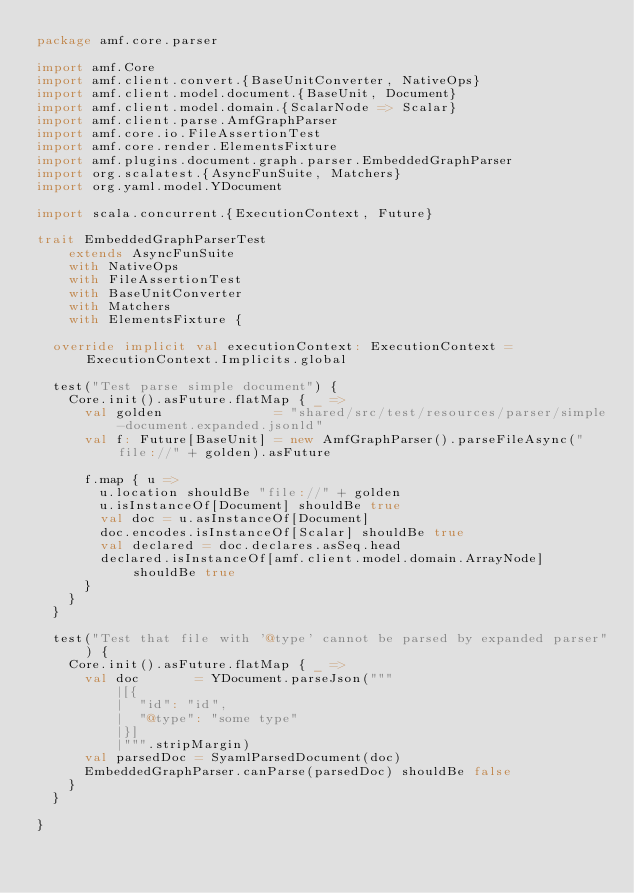<code> <loc_0><loc_0><loc_500><loc_500><_Scala_>package amf.core.parser

import amf.Core
import amf.client.convert.{BaseUnitConverter, NativeOps}
import amf.client.model.document.{BaseUnit, Document}
import amf.client.model.domain.{ScalarNode => Scalar}
import amf.client.parse.AmfGraphParser
import amf.core.io.FileAssertionTest
import amf.core.render.ElementsFixture
import amf.plugins.document.graph.parser.EmbeddedGraphParser
import org.scalatest.{AsyncFunSuite, Matchers}
import org.yaml.model.YDocument

import scala.concurrent.{ExecutionContext, Future}

trait EmbeddedGraphParserTest
    extends AsyncFunSuite
    with NativeOps
    with FileAssertionTest
    with BaseUnitConverter
    with Matchers
    with ElementsFixture {

  override implicit val executionContext: ExecutionContext = ExecutionContext.Implicits.global

  test("Test parse simple document") {
    Core.init().asFuture.flatMap { _ =>
      val golden              = "shared/src/test/resources/parser/simple-document.expanded.jsonld"
      val f: Future[BaseUnit] = new AmfGraphParser().parseFileAsync("file://" + golden).asFuture

      f.map { u =>
        u.location shouldBe "file://" + golden
        u.isInstanceOf[Document] shouldBe true
        val doc = u.asInstanceOf[Document]
        doc.encodes.isInstanceOf[Scalar] shouldBe true
        val declared = doc.declares.asSeq.head
        declared.isInstanceOf[amf.client.model.domain.ArrayNode] shouldBe true
      }
    }
  }

  test("Test that file with '@type' cannot be parsed by expanded parser") {
    Core.init().asFuture.flatMap { _ =>
      val doc       = YDocument.parseJson("""
          |[{
          |  "id": "id",
          |  "@type": "some type"
          |}]
          |""".stripMargin)
      val parsedDoc = SyamlParsedDocument(doc)
      EmbeddedGraphParser.canParse(parsedDoc) shouldBe false
    }
  }

}
</code> 